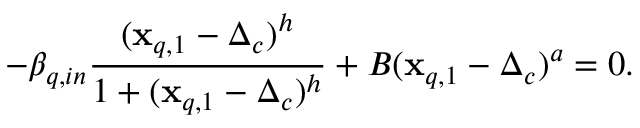Convert formula to latex. <formula><loc_0><loc_0><loc_500><loc_500>- \beta _ { q , i n } \frac { ( x _ { q , 1 } - \Delta _ { c } ) ^ { h } } { 1 + ( x _ { q , 1 } - \Delta _ { c } ) ^ { h } } + B ( x _ { q , 1 } - \Delta _ { c } ) ^ { a } = 0 .</formula> 